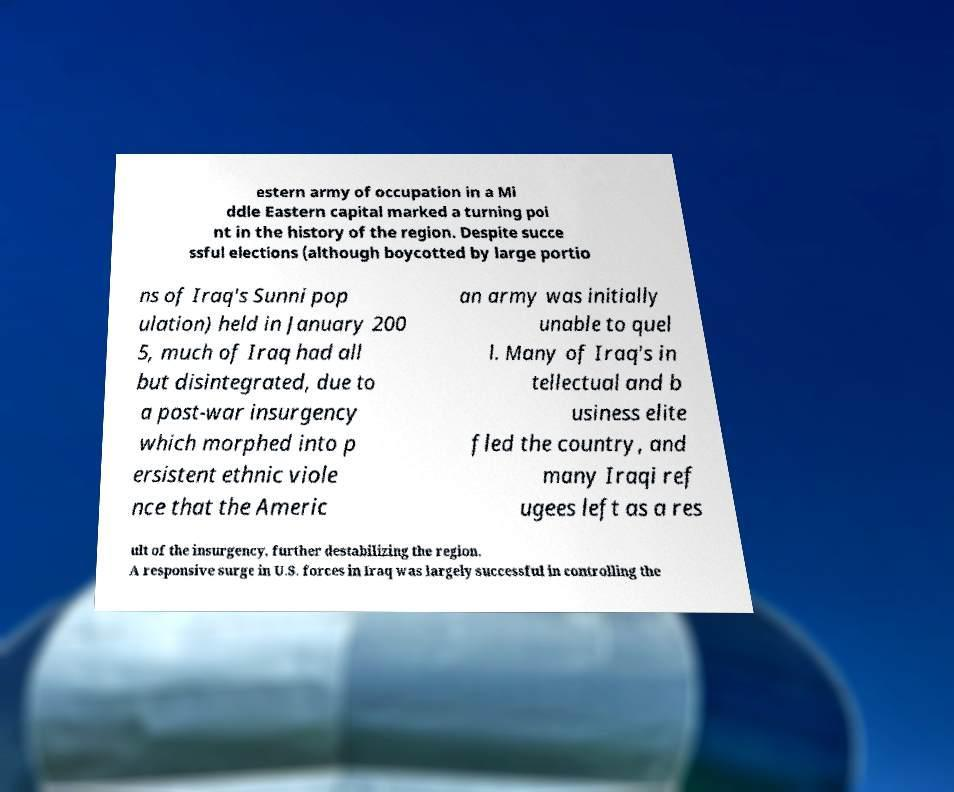I need the written content from this picture converted into text. Can you do that? estern army of occupation in a Mi ddle Eastern capital marked a turning poi nt in the history of the region. Despite succe ssful elections (although boycotted by large portio ns of Iraq's Sunni pop ulation) held in January 200 5, much of Iraq had all but disintegrated, due to a post-war insurgency which morphed into p ersistent ethnic viole nce that the Americ an army was initially unable to quel l. Many of Iraq's in tellectual and b usiness elite fled the country, and many Iraqi ref ugees left as a res ult of the insurgency, further destabilizing the region. A responsive surge in U.S. forces in Iraq was largely successful in controlling the 